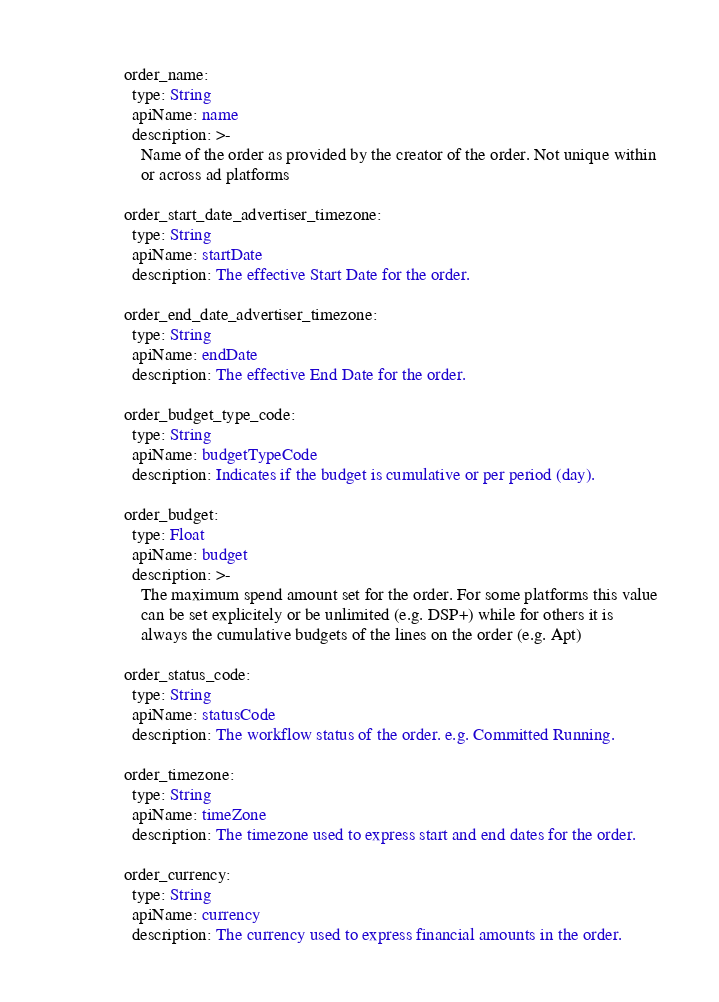Convert code to text. <code><loc_0><loc_0><loc_500><loc_500><_YAML_>
    order_name:
      type: String
      apiName: name
      description: >-
        Name of the order as provided by the creator of the order. Not unique within
        or across ad platforms

    order_start_date_advertiser_timezone:
      type: String
      apiName: startDate
      description: The effective Start Date for the order.

    order_end_date_advertiser_timezone:
      type: String
      apiName: endDate
      description: The effective End Date for the order.

    order_budget_type_code:
      type: String
      apiName: budgetTypeCode
      description: Indicates if the budget is cumulative or per period (day).

    order_budget:
      type: Float
      apiName: budget
      description: >-
        The maximum spend amount set for the order. For some platforms this value
        can be set explicitely or be unlimited (e.g. DSP+) while for others it is
        always the cumulative budgets of the lines on the order (e.g. Apt)

    order_status_code:
      type: String
      apiName: statusCode
      description: The workflow status of the order. e.g. Committed Running.

    order_timezone:
      type: String
      apiName: timeZone
      description: The timezone used to express start and end dates for the order.

    order_currency:
      type: String
      apiName: currency
      description: The currency used to express financial amounts in the order.
</code> 